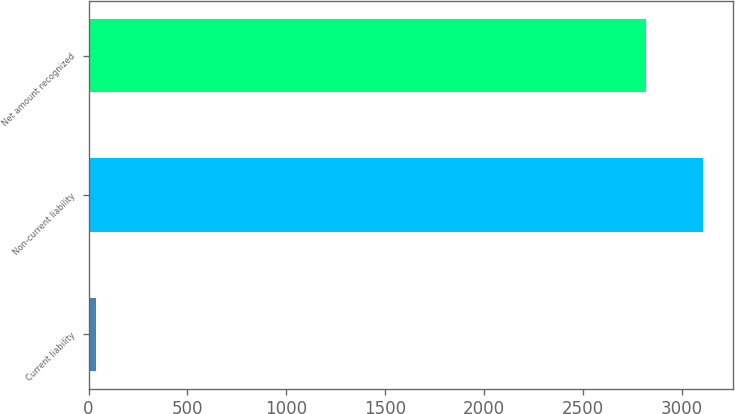Convert chart to OTSL. <chart><loc_0><loc_0><loc_500><loc_500><bar_chart><fcel>Current liability<fcel>Non-current liability<fcel>Net amount recognized<nl><fcel>38<fcel>3103.4<fcel>2819<nl></chart> 